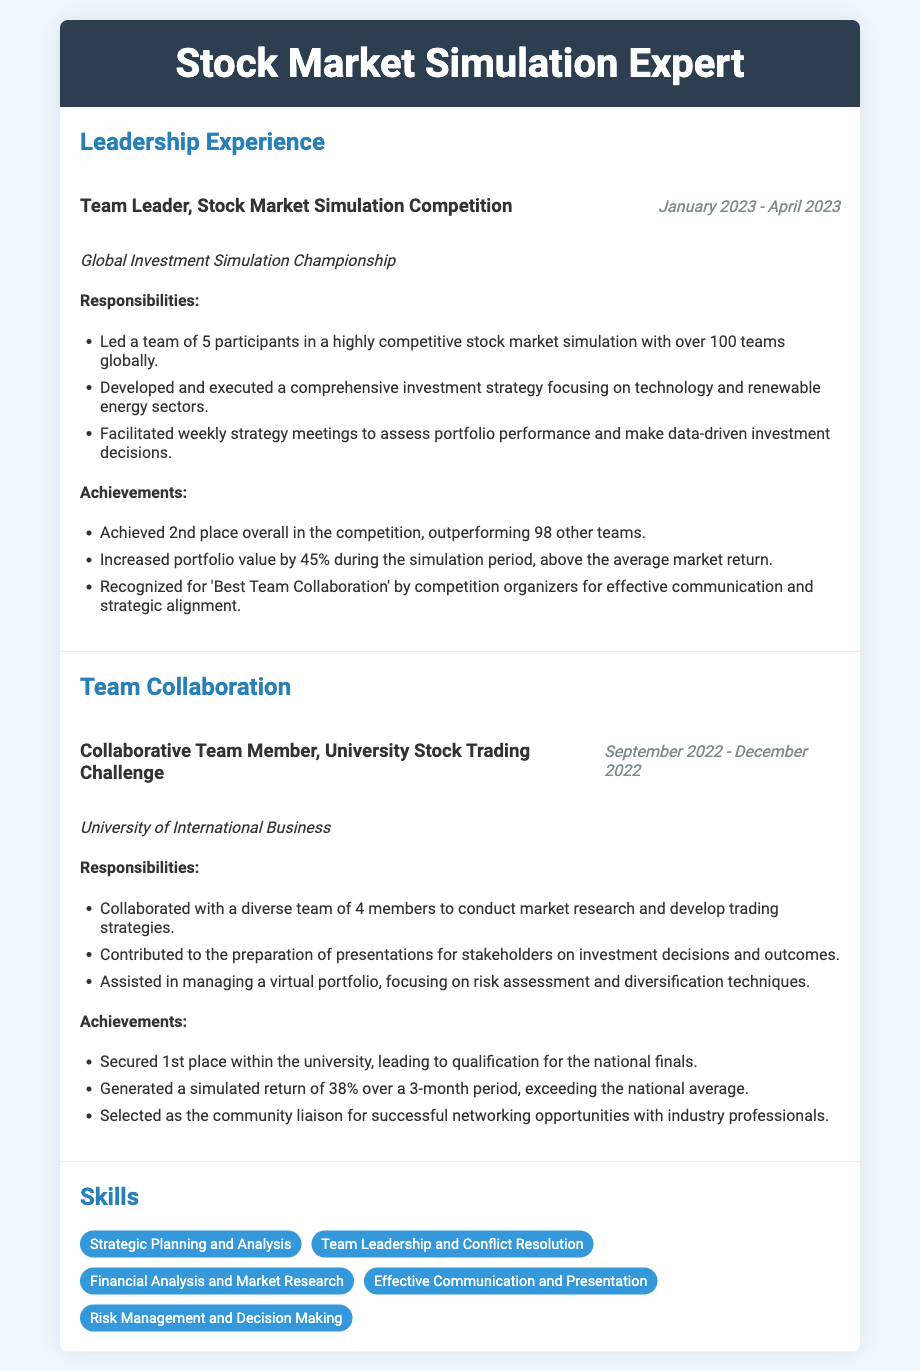What was the duration of the leadership experience? The duration of the leadership experience is given as January 2023 - April 2023.
Answer: January 2023 - April 2023 How many teams participated in the Global Investment Simulation Championship? The document states that there were over 100 teams globally in the competition.
Answer: Over 100 teams What was the portfolio value increase achieved during the simulation period? The document mentions an increase in portfolio value by 45% during the simulation period.
Answer: 45% Which sector was primarily focused on in the investment strategy? The document indicates that the investment strategy focused on the technology and renewable energy sectors.
Answer: Technology and renewable energy What place did the team achieve in the competition? According to the document, the team achieved 2nd place overall in the competition.
Answer: 2nd place What was the return generated over a 3-month period in the University Stock Trading Challenge? The document states that a simulated return of 38% was generated over a 3-month period.
Answer: 38% Who recognized the team for 'Best Team Collaboration'? The document mentions that the recognition for 'Best Team Collaboration' was given by the competition organizers.
Answer: Competition organizers What role did the individual serve in the University Stock Trading Challenge? The individual served as a collaborative team member in the University Stock Trading Challenge.
Answer: Collaborative Team Member 